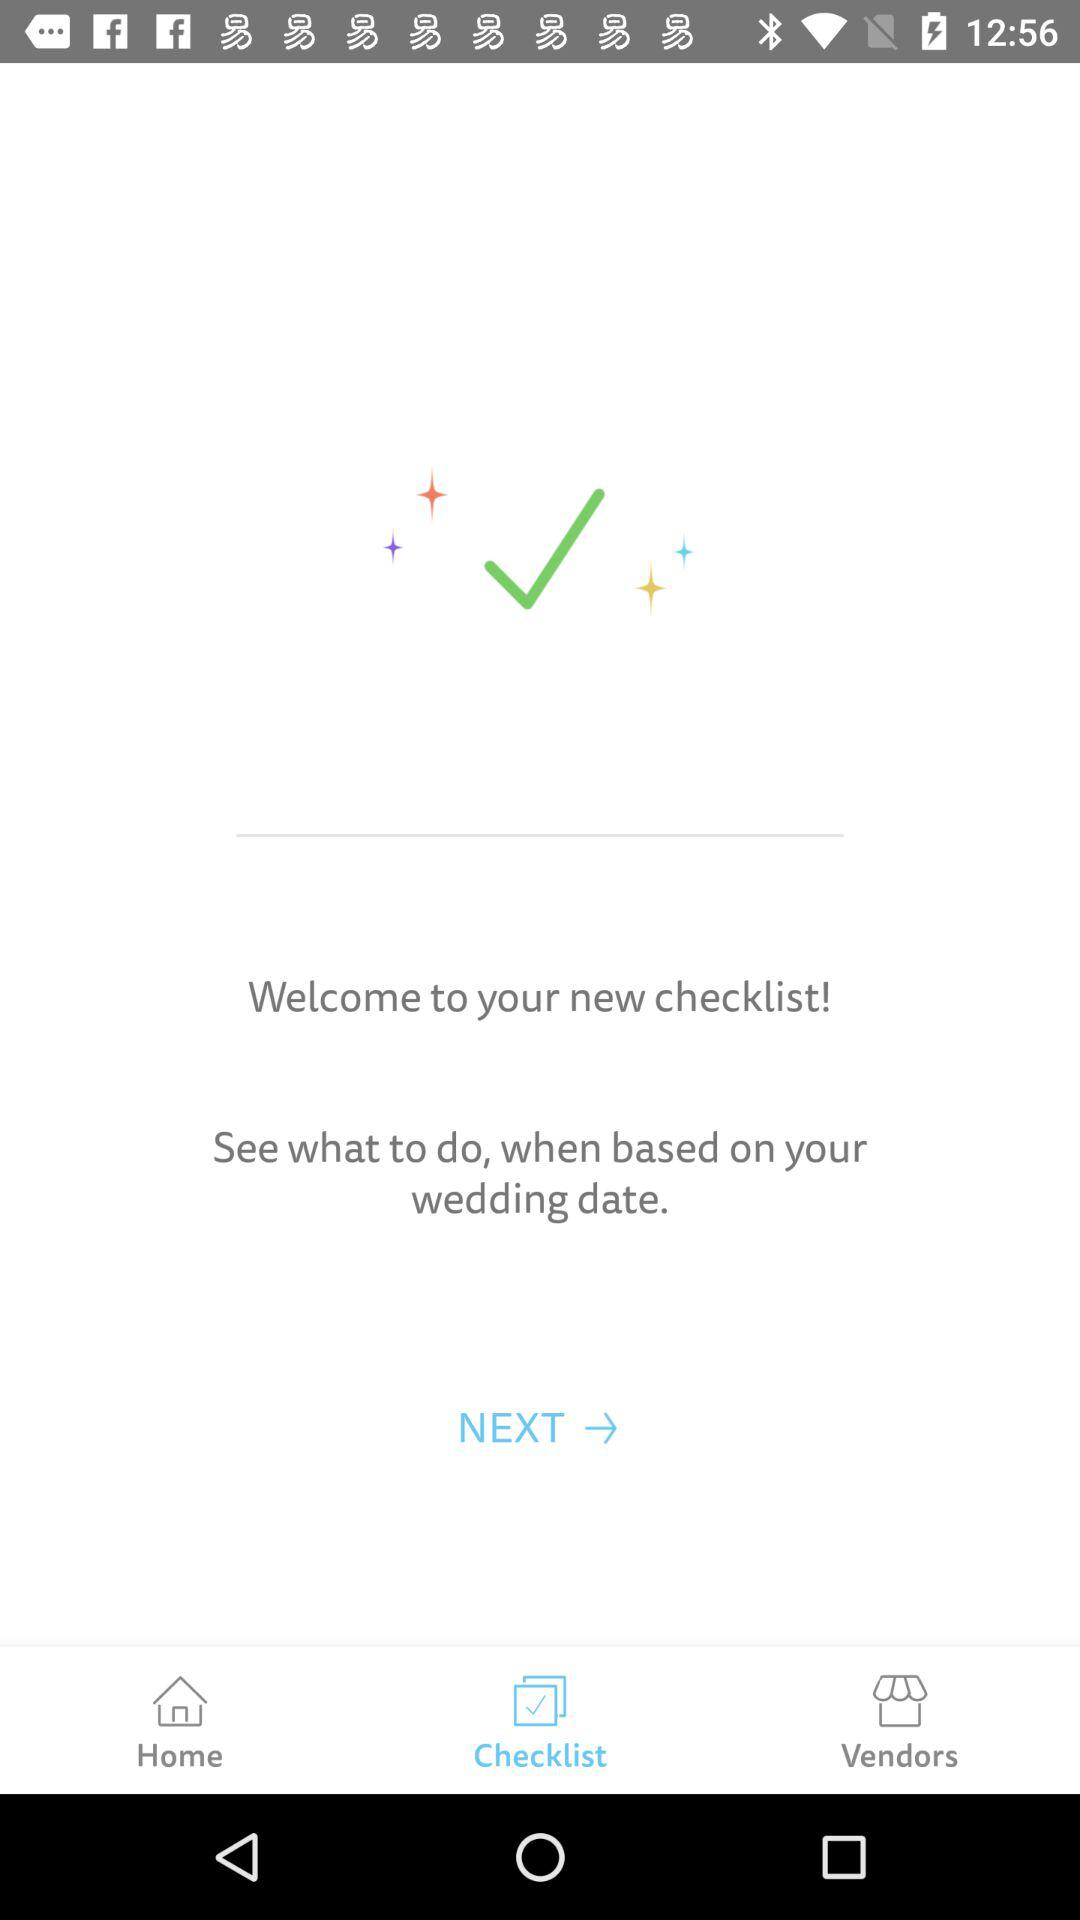Which tab is selected? The selected tab is "Checklist". 